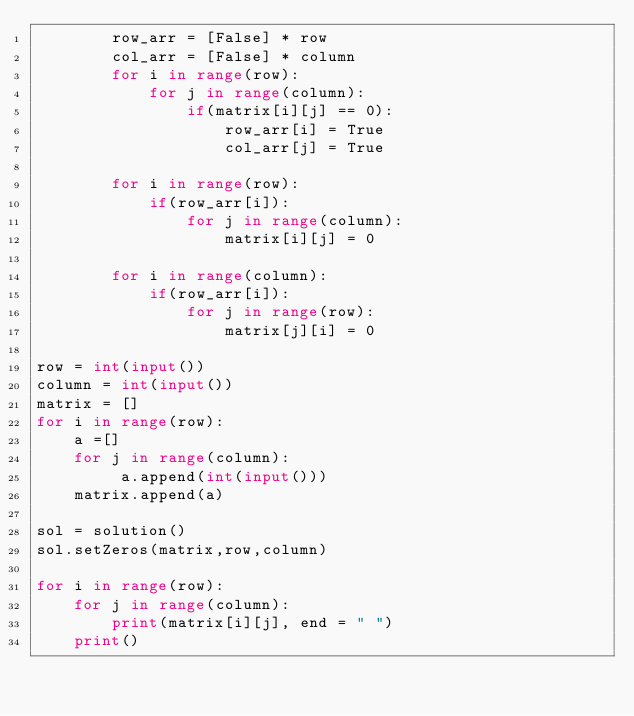Convert code to text. <code><loc_0><loc_0><loc_500><loc_500><_Python_>        row_arr = [False] * row
        col_arr = [False] * column
        for i in range(row):
            for j in range(column):
                if(matrix[i][j] == 0):
                    row_arr[i] = True
                    col_arr[j] = True

        for i in range(row):
            if(row_arr[i]):
                for j in range(column):
                    matrix[i][j] = 0

        for i in range(column):
            if(row_arr[i]):
                for j in range(row):
                    matrix[j][i] = 0

row = int(input())
column = int(input())
matrix = []
for i in range(row):
    a =[]
    for j in range(column):
         a.append(int(input()))
    matrix.append(a)

sol = solution()
sol.setZeros(matrix,row,column)

for i in range(row):
    for j in range(column):
        print(matrix[i][j], end = " ")
    print()
</code> 